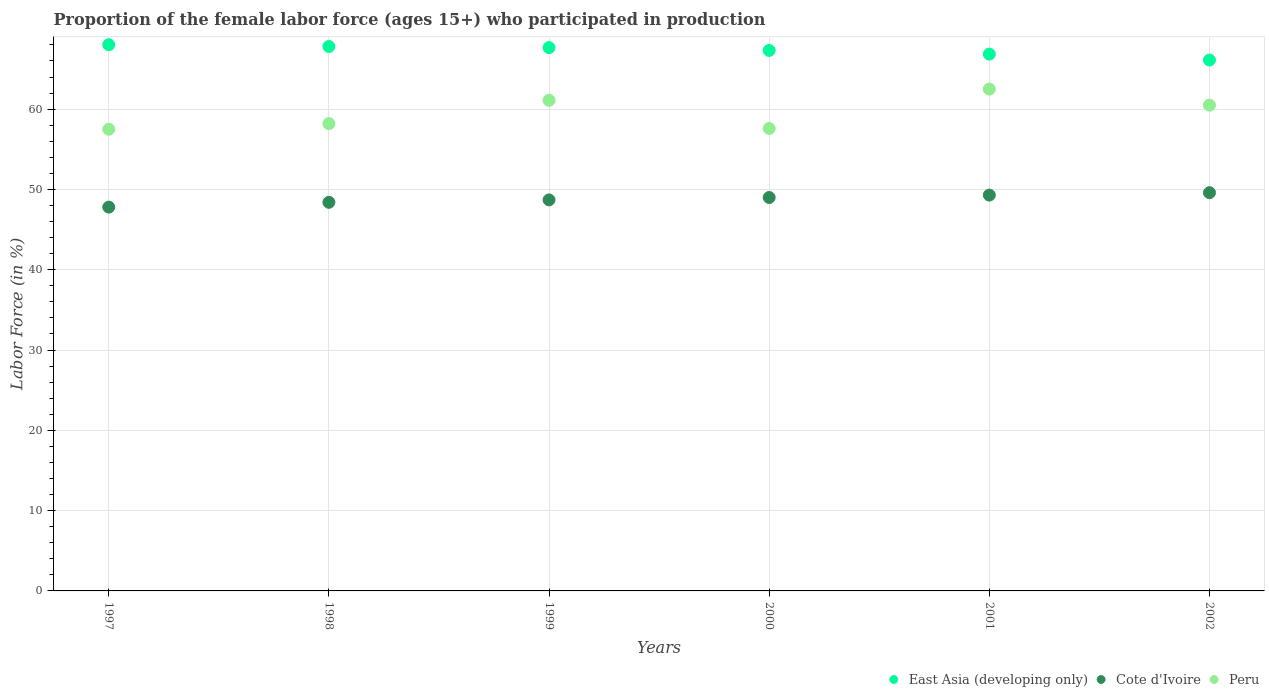How many different coloured dotlines are there?
Keep it short and to the point. 3. Is the number of dotlines equal to the number of legend labels?
Your answer should be very brief. Yes. What is the proportion of the female labor force who participated in production in East Asia (developing only) in 1997?
Provide a succinct answer. 68.03. Across all years, what is the maximum proportion of the female labor force who participated in production in East Asia (developing only)?
Provide a succinct answer. 68.03. Across all years, what is the minimum proportion of the female labor force who participated in production in East Asia (developing only)?
Offer a very short reply. 66.12. In which year was the proportion of the female labor force who participated in production in Cote d'Ivoire minimum?
Keep it short and to the point. 1997. What is the total proportion of the female labor force who participated in production in Peru in the graph?
Your answer should be compact. 357.4. What is the difference between the proportion of the female labor force who participated in production in Peru in 1999 and that in 2001?
Your answer should be very brief. -1.4. What is the difference between the proportion of the female labor force who participated in production in East Asia (developing only) in 2001 and the proportion of the female labor force who participated in production in Cote d'Ivoire in 2000?
Your answer should be compact. 17.85. What is the average proportion of the female labor force who participated in production in Cote d'Ivoire per year?
Your answer should be very brief. 48.8. In the year 2001, what is the difference between the proportion of the female labor force who participated in production in Peru and proportion of the female labor force who participated in production in East Asia (developing only)?
Provide a succinct answer. -4.35. In how many years, is the proportion of the female labor force who participated in production in Cote d'Ivoire greater than 28 %?
Provide a succinct answer. 6. What is the ratio of the proportion of the female labor force who participated in production in Peru in 1999 to that in 2000?
Ensure brevity in your answer.  1.06. Is the proportion of the female labor force who participated in production in East Asia (developing only) in 1997 less than that in 1999?
Make the answer very short. No. Is the difference between the proportion of the female labor force who participated in production in Peru in 1997 and 2000 greater than the difference between the proportion of the female labor force who participated in production in East Asia (developing only) in 1997 and 2000?
Keep it short and to the point. No. What is the difference between the highest and the second highest proportion of the female labor force who participated in production in Peru?
Keep it short and to the point. 1.4. Is the sum of the proportion of the female labor force who participated in production in Peru in 1997 and 2002 greater than the maximum proportion of the female labor force who participated in production in Cote d'Ivoire across all years?
Provide a short and direct response. Yes. Does the proportion of the female labor force who participated in production in Cote d'Ivoire monotonically increase over the years?
Offer a very short reply. Yes. Is the proportion of the female labor force who participated in production in Cote d'Ivoire strictly greater than the proportion of the female labor force who participated in production in Peru over the years?
Give a very brief answer. No. Is the proportion of the female labor force who participated in production in East Asia (developing only) strictly less than the proportion of the female labor force who participated in production in Peru over the years?
Provide a short and direct response. No. How many dotlines are there?
Keep it short and to the point. 3. Does the graph contain any zero values?
Provide a succinct answer. No. What is the title of the graph?
Your answer should be very brief. Proportion of the female labor force (ages 15+) who participated in production. What is the Labor Force (in %) of East Asia (developing only) in 1997?
Ensure brevity in your answer.  68.03. What is the Labor Force (in %) of Cote d'Ivoire in 1997?
Your answer should be very brief. 47.8. What is the Labor Force (in %) in Peru in 1997?
Your response must be concise. 57.5. What is the Labor Force (in %) of East Asia (developing only) in 1998?
Offer a terse response. 67.81. What is the Labor Force (in %) in Cote d'Ivoire in 1998?
Give a very brief answer. 48.4. What is the Labor Force (in %) in Peru in 1998?
Your answer should be compact. 58.2. What is the Labor Force (in %) of East Asia (developing only) in 1999?
Give a very brief answer. 67.67. What is the Labor Force (in %) of Cote d'Ivoire in 1999?
Give a very brief answer. 48.7. What is the Labor Force (in %) of Peru in 1999?
Your answer should be compact. 61.1. What is the Labor Force (in %) of East Asia (developing only) in 2000?
Keep it short and to the point. 67.32. What is the Labor Force (in %) of Peru in 2000?
Ensure brevity in your answer.  57.6. What is the Labor Force (in %) of East Asia (developing only) in 2001?
Provide a succinct answer. 66.85. What is the Labor Force (in %) of Cote d'Ivoire in 2001?
Ensure brevity in your answer.  49.3. What is the Labor Force (in %) in Peru in 2001?
Your answer should be compact. 62.5. What is the Labor Force (in %) in East Asia (developing only) in 2002?
Offer a terse response. 66.12. What is the Labor Force (in %) of Cote d'Ivoire in 2002?
Ensure brevity in your answer.  49.6. What is the Labor Force (in %) of Peru in 2002?
Provide a succinct answer. 60.5. Across all years, what is the maximum Labor Force (in %) of East Asia (developing only)?
Give a very brief answer. 68.03. Across all years, what is the maximum Labor Force (in %) of Cote d'Ivoire?
Offer a terse response. 49.6. Across all years, what is the maximum Labor Force (in %) in Peru?
Give a very brief answer. 62.5. Across all years, what is the minimum Labor Force (in %) in East Asia (developing only)?
Your answer should be very brief. 66.12. Across all years, what is the minimum Labor Force (in %) in Cote d'Ivoire?
Make the answer very short. 47.8. Across all years, what is the minimum Labor Force (in %) in Peru?
Make the answer very short. 57.5. What is the total Labor Force (in %) of East Asia (developing only) in the graph?
Your answer should be very brief. 403.8. What is the total Labor Force (in %) in Cote d'Ivoire in the graph?
Keep it short and to the point. 292.8. What is the total Labor Force (in %) of Peru in the graph?
Make the answer very short. 357.4. What is the difference between the Labor Force (in %) in East Asia (developing only) in 1997 and that in 1998?
Keep it short and to the point. 0.22. What is the difference between the Labor Force (in %) of Cote d'Ivoire in 1997 and that in 1998?
Offer a very short reply. -0.6. What is the difference between the Labor Force (in %) in Peru in 1997 and that in 1998?
Provide a short and direct response. -0.7. What is the difference between the Labor Force (in %) of East Asia (developing only) in 1997 and that in 1999?
Offer a very short reply. 0.36. What is the difference between the Labor Force (in %) of East Asia (developing only) in 1997 and that in 2000?
Offer a terse response. 0.71. What is the difference between the Labor Force (in %) in Cote d'Ivoire in 1997 and that in 2000?
Provide a short and direct response. -1.2. What is the difference between the Labor Force (in %) of East Asia (developing only) in 1997 and that in 2001?
Your answer should be very brief. 1.18. What is the difference between the Labor Force (in %) in Cote d'Ivoire in 1997 and that in 2001?
Keep it short and to the point. -1.5. What is the difference between the Labor Force (in %) of East Asia (developing only) in 1997 and that in 2002?
Offer a terse response. 1.91. What is the difference between the Labor Force (in %) in Cote d'Ivoire in 1997 and that in 2002?
Offer a terse response. -1.8. What is the difference between the Labor Force (in %) in East Asia (developing only) in 1998 and that in 1999?
Your response must be concise. 0.14. What is the difference between the Labor Force (in %) of Cote d'Ivoire in 1998 and that in 1999?
Keep it short and to the point. -0.3. What is the difference between the Labor Force (in %) in East Asia (developing only) in 1998 and that in 2000?
Provide a succinct answer. 0.49. What is the difference between the Labor Force (in %) in Cote d'Ivoire in 1998 and that in 2001?
Provide a short and direct response. -0.9. What is the difference between the Labor Force (in %) in Peru in 1998 and that in 2001?
Your answer should be compact. -4.3. What is the difference between the Labor Force (in %) of East Asia (developing only) in 1998 and that in 2002?
Provide a succinct answer. 1.69. What is the difference between the Labor Force (in %) in Cote d'Ivoire in 1998 and that in 2002?
Provide a succinct answer. -1.2. What is the difference between the Labor Force (in %) in Peru in 1998 and that in 2002?
Your answer should be very brief. -2.3. What is the difference between the Labor Force (in %) of East Asia (developing only) in 1999 and that in 2000?
Keep it short and to the point. 0.35. What is the difference between the Labor Force (in %) in Cote d'Ivoire in 1999 and that in 2000?
Give a very brief answer. -0.3. What is the difference between the Labor Force (in %) of Peru in 1999 and that in 2000?
Ensure brevity in your answer.  3.5. What is the difference between the Labor Force (in %) of East Asia (developing only) in 1999 and that in 2001?
Ensure brevity in your answer.  0.81. What is the difference between the Labor Force (in %) of Cote d'Ivoire in 1999 and that in 2001?
Your response must be concise. -0.6. What is the difference between the Labor Force (in %) of East Asia (developing only) in 1999 and that in 2002?
Ensure brevity in your answer.  1.55. What is the difference between the Labor Force (in %) in Cote d'Ivoire in 1999 and that in 2002?
Offer a very short reply. -0.9. What is the difference between the Labor Force (in %) of Peru in 1999 and that in 2002?
Keep it short and to the point. 0.6. What is the difference between the Labor Force (in %) in East Asia (developing only) in 2000 and that in 2001?
Your answer should be very brief. 0.46. What is the difference between the Labor Force (in %) in Peru in 2000 and that in 2001?
Offer a terse response. -4.9. What is the difference between the Labor Force (in %) in East Asia (developing only) in 2000 and that in 2002?
Provide a short and direct response. 1.2. What is the difference between the Labor Force (in %) in Cote d'Ivoire in 2000 and that in 2002?
Ensure brevity in your answer.  -0.6. What is the difference between the Labor Force (in %) in East Asia (developing only) in 2001 and that in 2002?
Provide a succinct answer. 0.73. What is the difference between the Labor Force (in %) in East Asia (developing only) in 1997 and the Labor Force (in %) in Cote d'Ivoire in 1998?
Provide a short and direct response. 19.63. What is the difference between the Labor Force (in %) of East Asia (developing only) in 1997 and the Labor Force (in %) of Peru in 1998?
Provide a short and direct response. 9.83. What is the difference between the Labor Force (in %) in East Asia (developing only) in 1997 and the Labor Force (in %) in Cote d'Ivoire in 1999?
Your answer should be very brief. 19.33. What is the difference between the Labor Force (in %) in East Asia (developing only) in 1997 and the Labor Force (in %) in Peru in 1999?
Ensure brevity in your answer.  6.93. What is the difference between the Labor Force (in %) in East Asia (developing only) in 1997 and the Labor Force (in %) in Cote d'Ivoire in 2000?
Your answer should be compact. 19.03. What is the difference between the Labor Force (in %) of East Asia (developing only) in 1997 and the Labor Force (in %) of Peru in 2000?
Provide a succinct answer. 10.43. What is the difference between the Labor Force (in %) in Cote d'Ivoire in 1997 and the Labor Force (in %) in Peru in 2000?
Give a very brief answer. -9.8. What is the difference between the Labor Force (in %) in East Asia (developing only) in 1997 and the Labor Force (in %) in Cote d'Ivoire in 2001?
Give a very brief answer. 18.73. What is the difference between the Labor Force (in %) in East Asia (developing only) in 1997 and the Labor Force (in %) in Peru in 2001?
Your answer should be compact. 5.53. What is the difference between the Labor Force (in %) of Cote d'Ivoire in 1997 and the Labor Force (in %) of Peru in 2001?
Your answer should be very brief. -14.7. What is the difference between the Labor Force (in %) of East Asia (developing only) in 1997 and the Labor Force (in %) of Cote d'Ivoire in 2002?
Keep it short and to the point. 18.43. What is the difference between the Labor Force (in %) of East Asia (developing only) in 1997 and the Labor Force (in %) of Peru in 2002?
Your response must be concise. 7.53. What is the difference between the Labor Force (in %) of Cote d'Ivoire in 1997 and the Labor Force (in %) of Peru in 2002?
Offer a terse response. -12.7. What is the difference between the Labor Force (in %) of East Asia (developing only) in 1998 and the Labor Force (in %) of Cote d'Ivoire in 1999?
Give a very brief answer. 19.11. What is the difference between the Labor Force (in %) in East Asia (developing only) in 1998 and the Labor Force (in %) in Peru in 1999?
Your answer should be compact. 6.71. What is the difference between the Labor Force (in %) of Cote d'Ivoire in 1998 and the Labor Force (in %) of Peru in 1999?
Keep it short and to the point. -12.7. What is the difference between the Labor Force (in %) in East Asia (developing only) in 1998 and the Labor Force (in %) in Cote d'Ivoire in 2000?
Ensure brevity in your answer.  18.81. What is the difference between the Labor Force (in %) of East Asia (developing only) in 1998 and the Labor Force (in %) of Peru in 2000?
Provide a succinct answer. 10.21. What is the difference between the Labor Force (in %) in East Asia (developing only) in 1998 and the Labor Force (in %) in Cote d'Ivoire in 2001?
Offer a terse response. 18.51. What is the difference between the Labor Force (in %) of East Asia (developing only) in 1998 and the Labor Force (in %) of Peru in 2001?
Offer a terse response. 5.31. What is the difference between the Labor Force (in %) of Cote d'Ivoire in 1998 and the Labor Force (in %) of Peru in 2001?
Make the answer very short. -14.1. What is the difference between the Labor Force (in %) of East Asia (developing only) in 1998 and the Labor Force (in %) of Cote d'Ivoire in 2002?
Make the answer very short. 18.21. What is the difference between the Labor Force (in %) in East Asia (developing only) in 1998 and the Labor Force (in %) in Peru in 2002?
Your answer should be compact. 7.31. What is the difference between the Labor Force (in %) in Cote d'Ivoire in 1998 and the Labor Force (in %) in Peru in 2002?
Make the answer very short. -12.1. What is the difference between the Labor Force (in %) in East Asia (developing only) in 1999 and the Labor Force (in %) in Cote d'Ivoire in 2000?
Your answer should be compact. 18.67. What is the difference between the Labor Force (in %) of East Asia (developing only) in 1999 and the Labor Force (in %) of Peru in 2000?
Provide a short and direct response. 10.07. What is the difference between the Labor Force (in %) in East Asia (developing only) in 1999 and the Labor Force (in %) in Cote d'Ivoire in 2001?
Your answer should be compact. 18.37. What is the difference between the Labor Force (in %) of East Asia (developing only) in 1999 and the Labor Force (in %) of Peru in 2001?
Your response must be concise. 5.17. What is the difference between the Labor Force (in %) of East Asia (developing only) in 1999 and the Labor Force (in %) of Cote d'Ivoire in 2002?
Your answer should be very brief. 18.07. What is the difference between the Labor Force (in %) in East Asia (developing only) in 1999 and the Labor Force (in %) in Peru in 2002?
Offer a terse response. 7.17. What is the difference between the Labor Force (in %) of East Asia (developing only) in 2000 and the Labor Force (in %) of Cote d'Ivoire in 2001?
Provide a short and direct response. 18.02. What is the difference between the Labor Force (in %) in East Asia (developing only) in 2000 and the Labor Force (in %) in Peru in 2001?
Your answer should be very brief. 4.82. What is the difference between the Labor Force (in %) in East Asia (developing only) in 2000 and the Labor Force (in %) in Cote d'Ivoire in 2002?
Your answer should be very brief. 17.72. What is the difference between the Labor Force (in %) in East Asia (developing only) in 2000 and the Labor Force (in %) in Peru in 2002?
Keep it short and to the point. 6.82. What is the difference between the Labor Force (in %) in Cote d'Ivoire in 2000 and the Labor Force (in %) in Peru in 2002?
Provide a succinct answer. -11.5. What is the difference between the Labor Force (in %) in East Asia (developing only) in 2001 and the Labor Force (in %) in Cote d'Ivoire in 2002?
Give a very brief answer. 17.25. What is the difference between the Labor Force (in %) of East Asia (developing only) in 2001 and the Labor Force (in %) of Peru in 2002?
Your answer should be very brief. 6.35. What is the average Labor Force (in %) in East Asia (developing only) per year?
Ensure brevity in your answer.  67.3. What is the average Labor Force (in %) of Cote d'Ivoire per year?
Provide a short and direct response. 48.8. What is the average Labor Force (in %) in Peru per year?
Make the answer very short. 59.57. In the year 1997, what is the difference between the Labor Force (in %) of East Asia (developing only) and Labor Force (in %) of Cote d'Ivoire?
Provide a succinct answer. 20.23. In the year 1997, what is the difference between the Labor Force (in %) in East Asia (developing only) and Labor Force (in %) in Peru?
Your answer should be compact. 10.53. In the year 1998, what is the difference between the Labor Force (in %) of East Asia (developing only) and Labor Force (in %) of Cote d'Ivoire?
Ensure brevity in your answer.  19.41. In the year 1998, what is the difference between the Labor Force (in %) in East Asia (developing only) and Labor Force (in %) in Peru?
Your answer should be very brief. 9.61. In the year 1999, what is the difference between the Labor Force (in %) of East Asia (developing only) and Labor Force (in %) of Cote d'Ivoire?
Provide a short and direct response. 18.97. In the year 1999, what is the difference between the Labor Force (in %) in East Asia (developing only) and Labor Force (in %) in Peru?
Make the answer very short. 6.57. In the year 2000, what is the difference between the Labor Force (in %) in East Asia (developing only) and Labor Force (in %) in Cote d'Ivoire?
Ensure brevity in your answer.  18.32. In the year 2000, what is the difference between the Labor Force (in %) of East Asia (developing only) and Labor Force (in %) of Peru?
Provide a succinct answer. 9.72. In the year 2000, what is the difference between the Labor Force (in %) of Cote d'Ivoire and Labor Force (in %) of Peru?
Provide a succinct answer. -8.6. In the year 2001, what is the difference between the Labor Force (in %) of East Asia (developing only) and Labor Force (in %) of Cote d'Ivoire?
Provide a short and direct response. 17.55. In the year 2001, what is the difference between the Labor Force (in %) in East Asia (developing only) and Labor Force (in %) in Peru?
Make the answer very short. 4.35. In the year 2001, what is the difference between the Labor Force (in %) of Cote d'Ivoire and Labor Force (in %) of Peru?
Your answer should be compact. -13.2. In the year 2002, what is the difference between the Labor Force (in %) in East Asia (developing only) and Labor Force (in %) in Cote d'Ivoire?
Ensure brevity in your answer.  16.52. In the year 2002, what is the difference between the Labor Force (in %) of East Asia (developing only) and Labor Force (in %) of Peru?
Your response must be concise. 5.62. In the year 2002, what is the difference between the Labor Force (in %) in Cote d'Ivoire and Labor Force (in %) in Peru?
Your answer should be very brief. -10.9. What is the ratio of the Labor Force (in %) of East Asia (developing only) in 1997 to that in 1998?
Make the answer very short. 1. What is the ratio of the Labor Force (in %) of Cote d'Ivoire in 1997 to that in 1998?
Give a very brief answer. 0.99. What is the ratio of the Labor Force (in %) of Peru in 1997 to that in 1998?
Your answer should be very brief. 0.99. What is the ratio of the Labor Force (in %) in East Asia (developing only) in 1997 to that in 1999?
Keep it short and to the point. 1.01. What is the ratio of the Labor Force (in %) in Cote d'Ivoire in 1997 to that in 1999?
Provide a short and direct response. 0.98. What is the ratio of the Labor Force (in %) in Peru in 1997 to that in 1999?
Ensure brevity in your answer.  0.94. What is the ratio of the Labor Force (in %) of East Asia (developing only) in 1997 to that in 2000?
Give a very brief answer. 1.01. What is the ratio of the Labor Force (in %) of Cote d'Ivoire in 1997 to that in 2000?
Your answer should be compact. 0.98. What is the ratio of the Labor Force (in %) in Peru in 1997 to that in 2000?
Provide a short and direct response. 1. What is the ratio of the Labor Force (in %) in East Asia (developing only) in 1997 to that in 2001?
Make the answer very short. 1.02. What is the ratio of the Labor Force (in %) of Cote d'Ivoire in 1997 to that in 2001?
Offer a terse response. 0.97. What is the ratio of the Labor Force (in %) in Peru in 1997 to that in 2001?
Give a very brief answer. 0.92. What is the ratio of the Labor Force (in %) of East Asia (developing only) in 1997 to that in 2002?
Ensure brevity in your answer.  1.03. What is the ratio of the Labor Force (in %) in Cote d'Ivoire in 1997 to that in 2002?
Your answer should be compact. 0.96. What is the ratio of the Labor Force (in %) of Peru in 1997 to that in 2002?
Ensure brevity in your answer.  0.95. What is the ratio of the Labor Force (in %) of Cote d'Ivoire in 1998 to that in 1999?
Make the answer very short. 0.99. What is the ratio of the Labor Force (in %) of Peru in 1998 to that in 1999?
Your answer should be compact. 0.95. What is the ratio of the Labor Force (in %) of Peru in 1998 to that in 2000?
Your response must be concise. 1.01. What is the ratio of the Labor Force (in %) in East Asia (developing only) in 1998 to that in 2001?
Ensure brevity in your answer.  1.01. What is the ratio of the Labor Force (in %) of Cote d'Ivoire in 1998 to that in 2001?
Ensure brevity in your answer.  0.98. What is the ratio of the Labor Force (in %) in Peru in 1998 to that in 2001?
Provide a succinct answer. 0.93. What is the ratio of the Labor Force (in %) in East Asia (developing only) in 1998 to that in 2002?
Keep it short and to the point. 1.03. What is the ratio of the Labor Force (in %) in Cote d'Ivoire in 1998 to that in 2002?
Make the answer very short. 0.98. What is the ratio of the Labor Force (in %) in Peru in 1998 to that in 2002?
Provide a short and direct response. 0.96. What is the ratio of the Labor Force (in %) in Cote d'Ivoire in 1999 to that in 2000?
Your answer should be compact. 0.99. What is the ratio of the Labor Force (in %) in Peru in 1999 to that in 2000?
Make the answer very short. 1.06. What is the ratio of the Labor Force (in %) of East Asia (developing only) in 1999 to that in 2001?
Your response must be concise. 1.01. What is the ratio of the Labor Force (in %) of Cote d'Ivoire in 1999 to that in 2001?
Make the answer very short. 0.99. What is the ratio of the Labor Force (in %) of Peru in 1999 to that in 2001?
Provide a short and direct response. 0.98. What is the ratio of the Labor Force (in %) in East Asia (developing only) in 1999 to that in 2002?
Keep it short and to the point. 1.02. What is the ratio of the Labor Force (in %) of Cote d'Ivoire in 1999 to that in 2002?
Provide a short and direct response. 0.98. What is the ratio of the Labor Force (in %) of Peru in 1999 to that in 2002?
Provide a short and direct response. 1.01. What is the ratio of the Labor Force (in %) of Cote d'Ivoire in 2000 to that in 2001?
Make the answer very short. 0.99. What is the ratio of the Labor Force (in %) in Peru in 2000 to that in 2001?
Offer a terse response. 0.92. What is the ratio of the Labor Force (in %) of East Asia (developing only) in 2000 to that in 2002?
Your answer should be very brief. 1.02. What is the ratio of the Labor Force (in %) of Cote d'Ivoire in 2000 to that in 2002?
Offer a terse response. 0.99. What is the ratio of the Labor Force (in %) in Peru in 2000 to that in 2002?
Your answer should be very brief. 0.95. What is the ratio of the Labor Force (in %) of East Asia (developing only) in 2001 to that in 2002?
Provide a short and direct response. 1.01. What is the ratio of the Labor Force (in %) in Peru in 2001 to that in 2002?
Your answer should be compact. 1.03. What is the difference between the highest and the second highest Labor Force (in %) of East Asia (developing only)?
Offer a terse response. 0.22. What is the difference between the highest and the second highest Labor Force (in %) in Cote d'Ivoire?
Offer a terse response. 0.3. What is the difference between the highest and the second highest Labor Force (in %) in Peru?
Your answer should be compact. 1.4. What is the difference between the highest and the lowest Labor Force (in %) of East Asia (developing only)?
Offer a very short reply. 1.91. What is the difference between the highest and the lowest Labor Force (in %) of Cote d'Ivoire?
Provide a short and direct response. 1.8. What is the difference between the highest and the lowest Labor Force (in %) in Peru?
Offer a terse response. 5. 